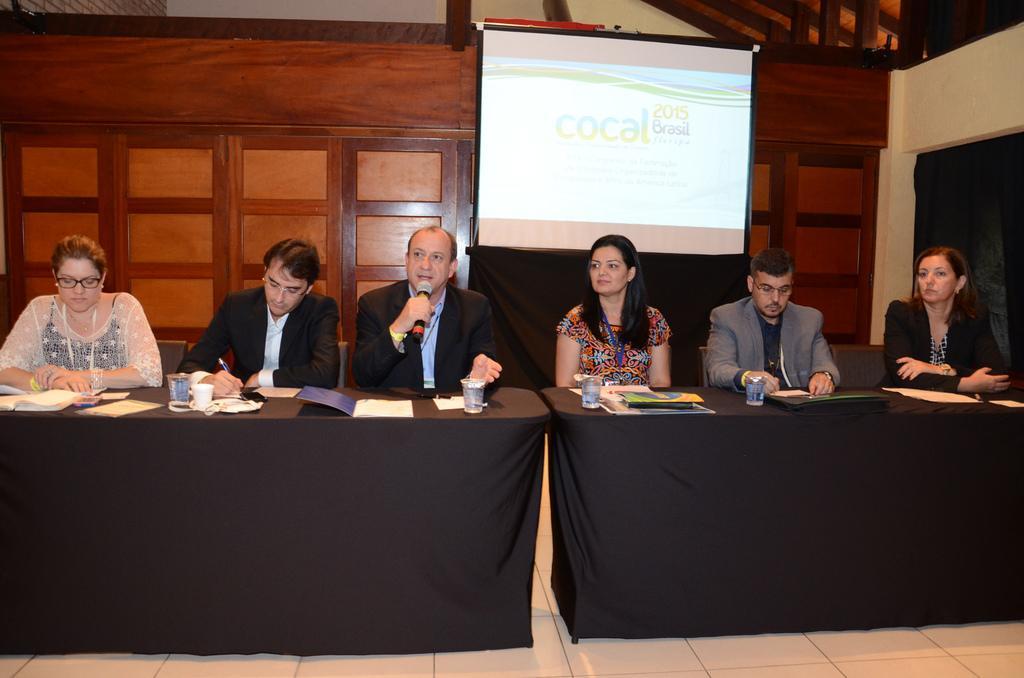Can you describe this image briefly? In this picture there are six members sitting in front of a tables. On the table there are some papers glasses and files are placed here. There are men and women in this group. In the Background there is a projector display screen and a wooden wall here. 